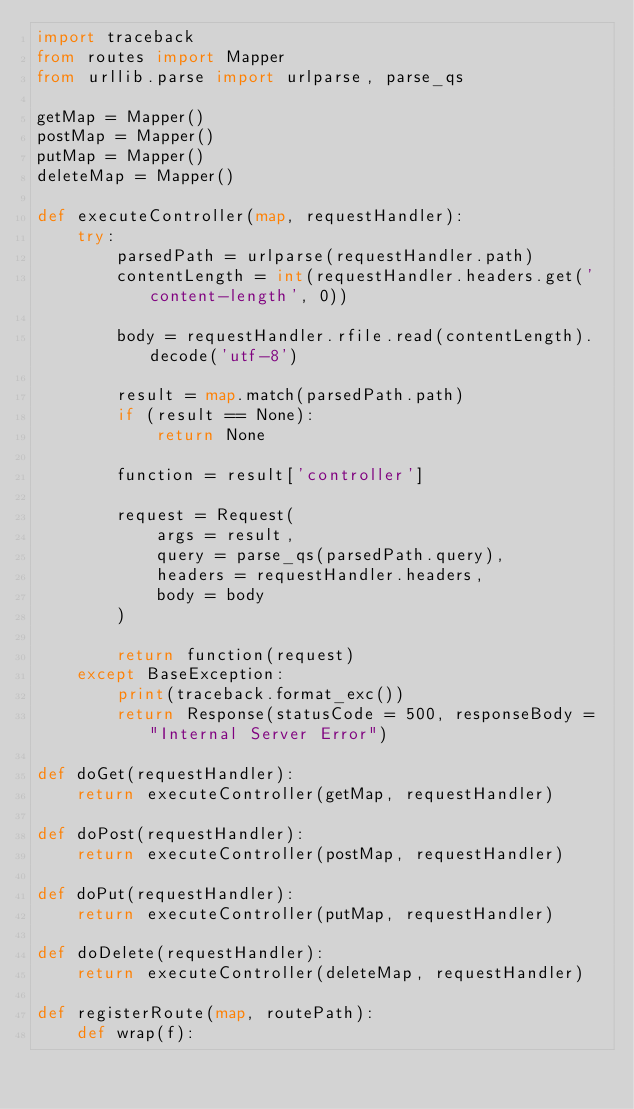<code> <loc_0><loc_0><loc_500><loc_500><_Python_>import traceback
from routes import Mapper
from urllib.parse import urlparse, parse_qs

getMap = Mapper()
postMap = Mapper()
putMap = Mapper()
deleteMap = Mapper()

def executeController(map, requestHandler):
    try:
        parsedPath = urlparse(requestHandler.path)
        contentLength = int(requestHandler.headers.get('content-length', 0))

        body = requestHandler.rfile.read(contentLength).decode('utf-8')

        result = map.match(parsedPath.path)
        if (result == None):
            return None

        function = result['controller']

        request = Request(
            args = result,
            query = parse_qs(parsedPath.query),
            headers = requestHandler.headers,
            body = body
        )

        return function(request)
    except BaseException:
        print(traceback.format_exc())
        return Response(statusCode = 500, responseBody = "Internal Server Error")

def doGet(requestHandler):
    return executeController(getMap, requestHandler)

def doPost(requestHandler):
    return executeController(postMap, requestHandler)

def doPut(requestHandler):
    return executeController(putMap, requestHandler)

def doDelete(requestHandler):
    return executeController(deleteMap, requestHandler)

def registerRoute(map, routePath):
    def wrap(f):</code> 